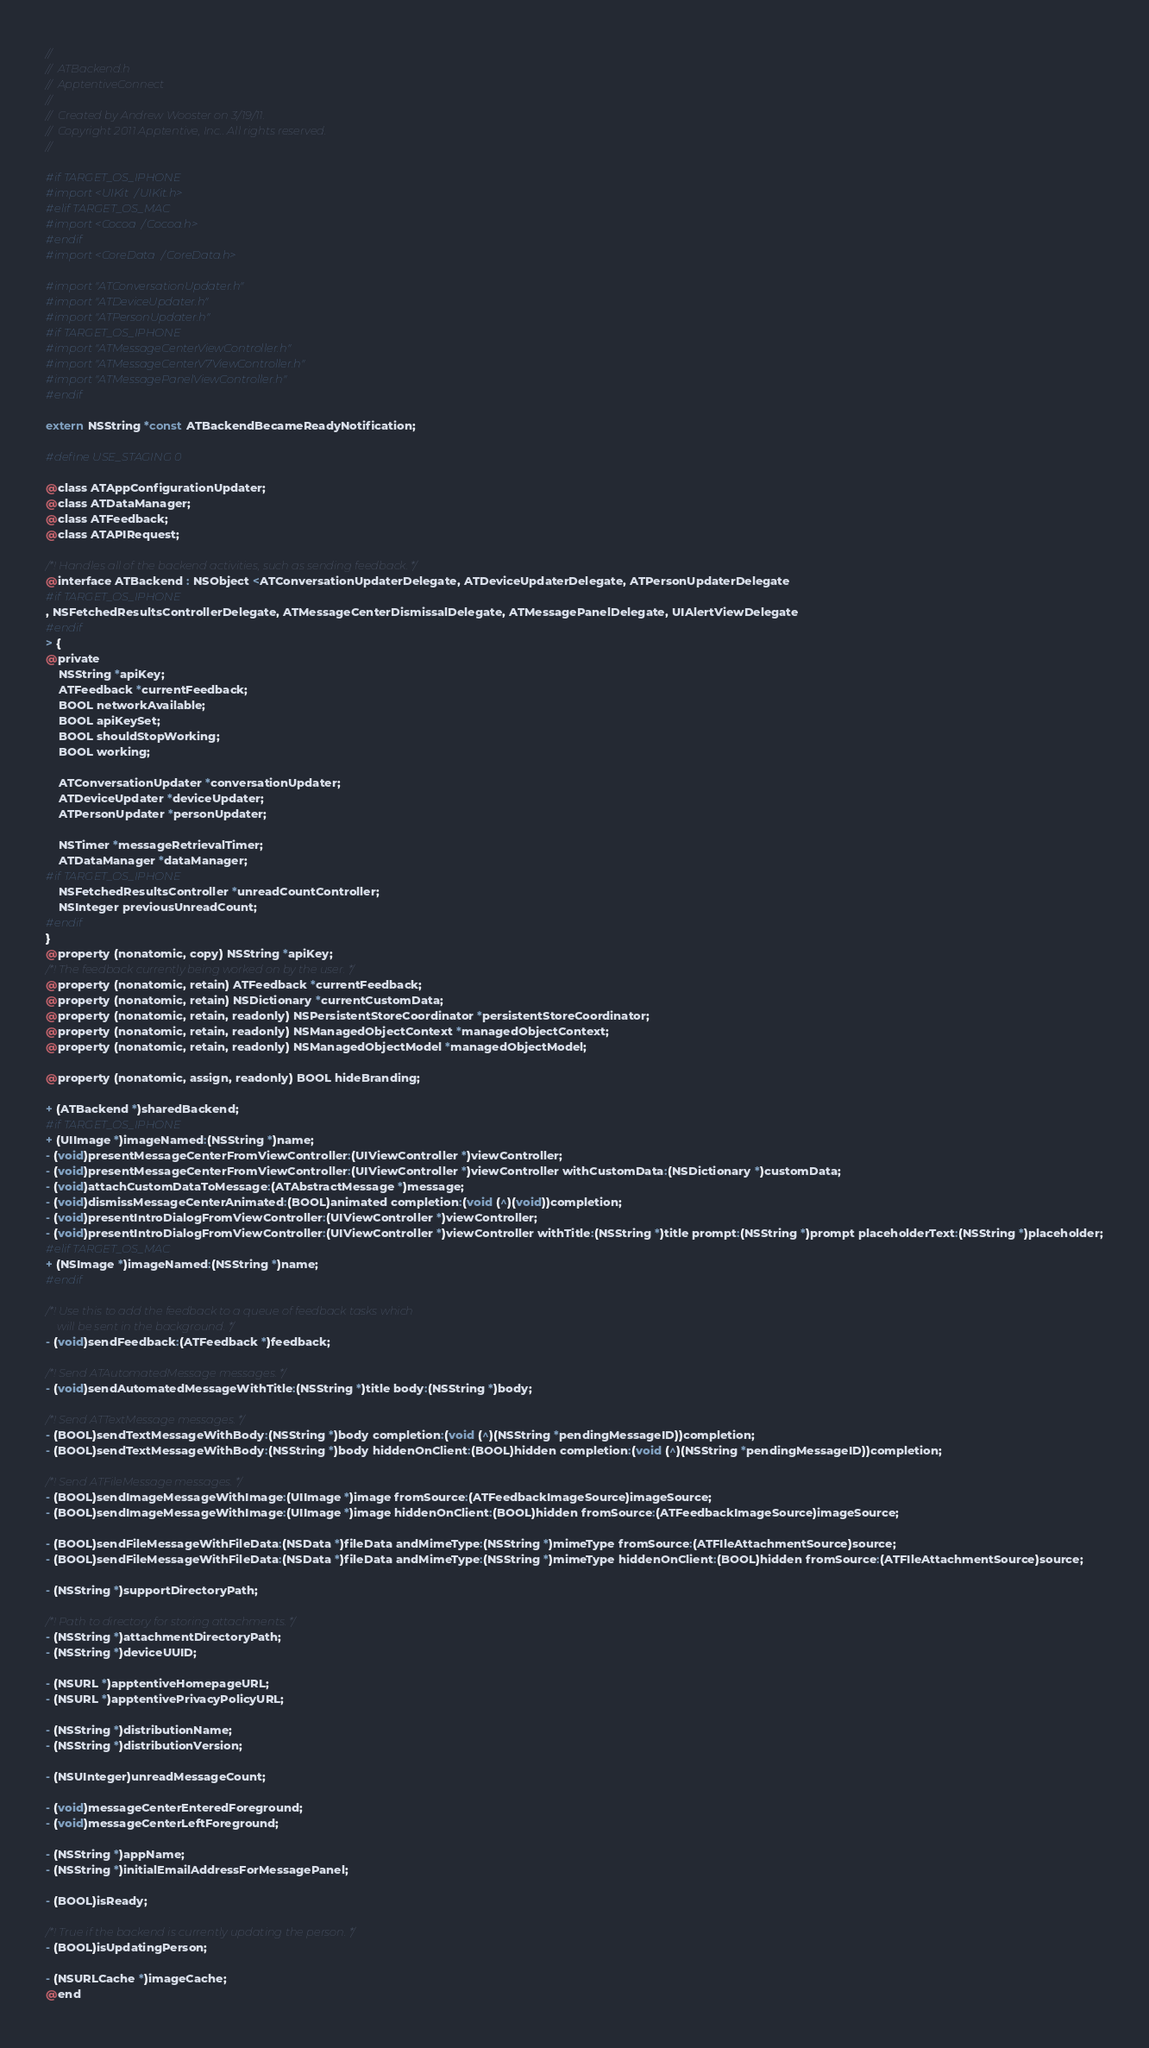<code> <loc_0><loc_0><loc_500><loc_500><_C_>//
//  ATBackend.h
//  ApptentiveConnect
//
//  Created by Andrew Wooster on 3/19/11.
//  Copyright 2011 Apptentive, Inc.. All rights reserved.
//

#if TARGET_OS_IPHONE
#import <UIKit/UIKit.h>
#elif TARGET_OS_MAC
#import <Cocoa/Cocoa.h>
#endif
#import <CoreData/CoreData.h>

#import "ATConversationUpdater.h"
#import "ATDeviceUpdater.h"
#import "ATPersonUpdater.h"
#if TARGET_OS_IPHONE
#import "ATMessageCenterViewController.h"
#import "ATMessageCenterV7ViewController.h"
#import "ATMessagePanelViewController.h"
#endif

extern NSString *const ATBackendBecameReadyNotification;

#define USE_STAGING 0

@class ATAppConfigurationUpdater;
@class ATDataManager;
@class ATFeedback;
@class ATAPIRequest;

/*! Handles all of the backend activities, such as sending feedback. */
@interface ATBackend : NSObject <ATConversationUpdaterDelegate, ATDeviceUpdaterDelegate, ATPersonUpdaterDelegate
#if TARGET_OS_IPHONE
, NSFetchedResultsControllerDelegate, ATMessageCenterDismissalDelegate, ATMessagePanelDelegate, UIAlertViewDelegate
#endif
> {
@private
	NSString *apiKey;
	ATFeedback *currentFeedback;
	BOOL networkAvailable;
	BOOL apiKeySet;
	BOOL shouldStopWorking;
	BOOL working;
	
	ATConversationUpdater *conversationUpdater;
	ATDeviceUpdater *deviceUpdater;
	ATPersonUpdater *personUpdater;
	
	NSTimer *messageRetrievalTimer;
	ATDataManager *dataManager;
#if TARGET_OS_IPHONE
	NSFetchedResultsController *unreadCountController;
	NSInteger previousUnreadCount;
#endif
}
@property (nonatomic, copy) NSString *apiKey;
/*! The feedback currently being worked on by the user. */
@property (nonatomic, retain) ATFeedback *currentFeedback;
@property (nonatomic, retain) NSDictionary *currentCustomData;
@property (nonatomic, retain, readonly) NSPersistentStoreCoordinator *persistentStoreCoordinator;
@property (nonatomic, retain, readonly) NSManagedObjectContext *managedObjectContext;
@property (nonatomic, retain, readonly) NSManagedObjectModel *managedObjectModel;

@property (nonatomic, assign, readonly) BOOL hideBranding;

+ (ATBackend *)sharedBackend;
#if TARGET_OS_IPHONE
+ (UIImage *)imageNamed:(NSString *)name;
- (void)presentMessageCenterFromViewController:(UIViewController *)viewController;
- (void)presentMessageCenterFromViewController:(UIViewController *)viewController withCustomData:(NSDictionary *)customData;
- (void)attachCustomDataToMessage:(ATAbstractMessage *)message;
- (void)dismissMessageCenterAnimated:(BOOL)animated completion:(void (^)(void))completion;
- (void)presentIntroDialogFromViewController:(UIViewController *)viewController;
- (void)presentIntroDialogFromViewController:(UIViewController *)viewController withTitle:(NSString *)title prompt:(NSString *)prompt placeholderText:(NSString *)placeholder;
#elif TARGET_OS_MAC
+ (NSImage *)imageNamed:(NSString *)name;
#endif

/*! Use this to add the feedback to a queue of feedback tasks which
    will be sent in the background. */
- (void)sendFeedback:(ATFeedback *)feedback;

/*! Send ATAutomatedMessage messages. */
- (void)sendAutomatedMessageWithTitle:(NSString *)title body:(NSString *)body;

/*! Send ATTextMessage messages. */
- (BOOL)sendTextMessageWithBody:(NSString *)body completion:(void (^)(NSString *pendingMessageID))completion;
- (BOOL)sendTextMessageWithBody:(NSString *)body hiddenOnClient:(BOOL)hidden completion:(void (^)(NSString *pendingMessageID))completion;

/*! Send ATFileMessage messages. */
- (BOOL)sendImageMessageWithImage:(UIImage *)image fromSource:(ATFeedbackImageSource)imageSource;
- (BOOL)sendImageMessageWithImage:(UIImage *)image hiddenOnClient:(BOOL)hidden fromSource:(ATFeedbackImageSource)imageSource;

- (BOOL)sendFileMessageWithFileData:(NSData *)fileData andMimeType:(NSString *)mimeType fromSource:(ATFIleAttachmentSource)source;
- (BOOL)sendFileMessageWithFileData:(NSData *)fileData andMimeType:(NSString *)mimeType hiddenOnClient:(BOOL)hidden fromSource:(ATFIleAttachmentSource)source;

- (NSString *)supportDirectoryPath;

/*! Path to directory for storing attachments. */
- (NSString *)attachmentDirectoryPath;
- (NSString *)deviceUUID;

- (NSURL *)apptentiveHomepageURL;
- (NSURL *)apptentivePrivacyPolicyURL;

- (NSString *)distributionName;
- (NSString *)distributionVersion;

- (NSUInteger)unreadMessageCount;

- (void)messageCenterEnteredForeground;
- (void)messageCenterLeftForeground;

- (NSString *)appName;
- (NSString *)initialEmailAddressForMessagePanel;

- (BOOL)isReady;

/*! True if the backend is currently updating the person. */
- (BOOL)isUpdatingPerson;

- (NSURLCache *)imageCache;
@end
</code> 